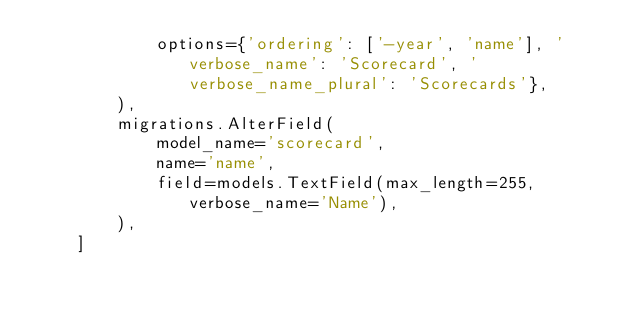Convert code to text. <code><loc_0><loc_0><loc_500><loc_500><_Python_>            options={'ordering': ['-year', 'name'], 'verbose_name': 'Scorecard', 'verbose_name_plural': 'Scorecards'},
        ),
        migrations.AlterField(
            model_name='scorecard',
            name='name',
            field=models.TextField(max_length=255, verbose_name='Name'),
        ),
    ]
</code> 